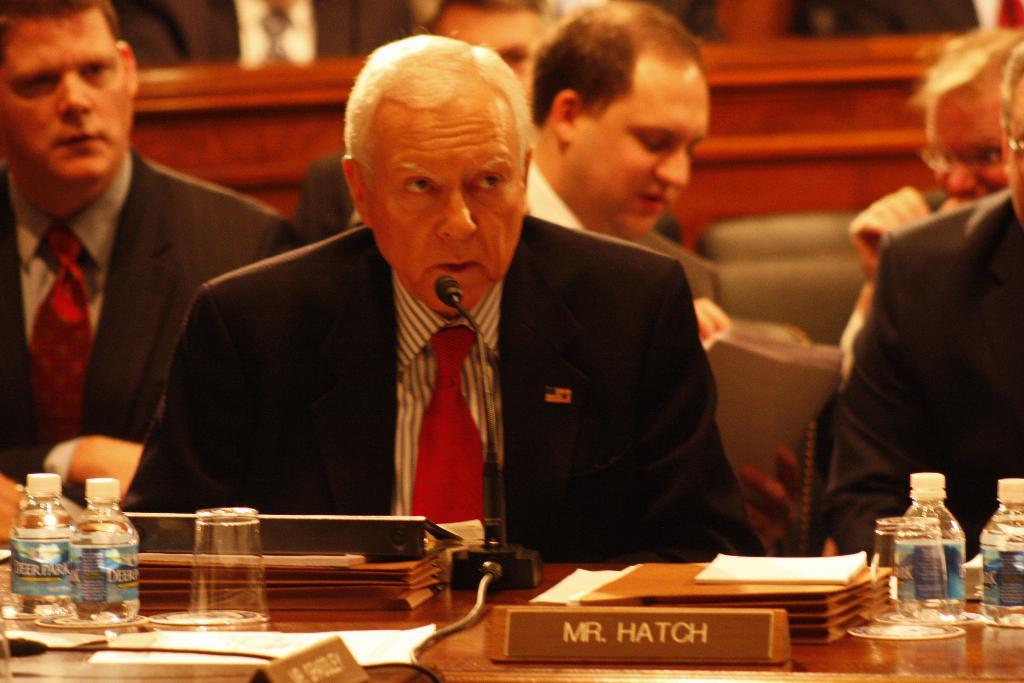How would you summarize this image in a sentence or two? In the image we can see there are people who are sitting on chair and in front of the man there is mic with a stand and on table there is name plate, bottle, files and a glass. 